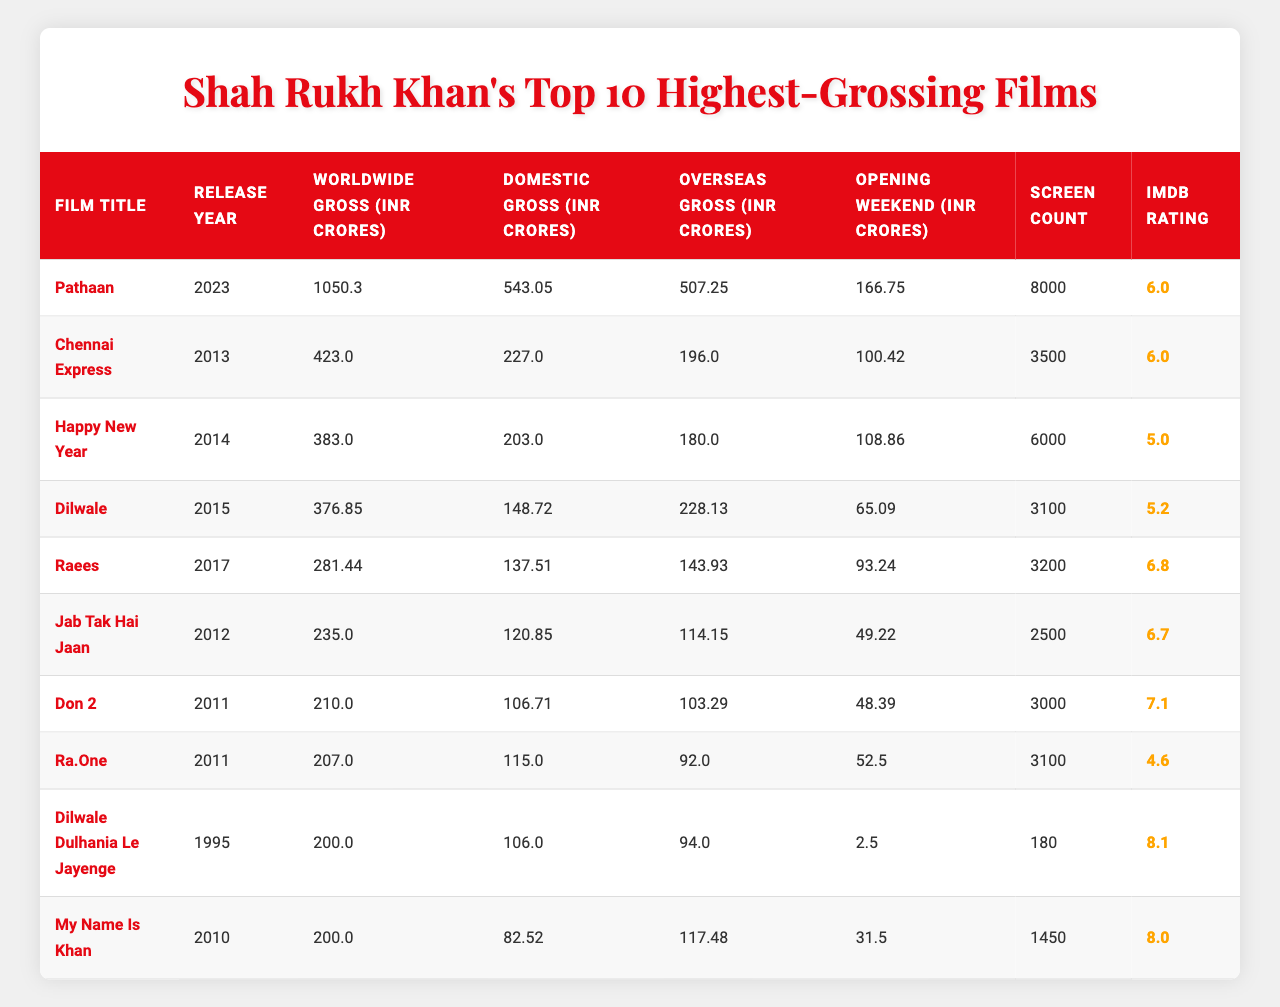What is the highest worldwide gross for a Shah Rukh Khan film? According to the table, the film "Pathaan" has the highest worldwide gross of 1050.30 INR Crores.
Answer: 1050.30 INR Crores Which film was released in 2014 and grossed over 380 INR Crores worldwide? The film "Happy New Year," released in 2014, grossed 383.00 INR Crores worldwide, which is over 380 INR Crores.
Answer: Yes What is the difference between the domestic gross of "Chennai Express" and "Raees"? The domestic gross of "Chennai Express" is 227.00 INR Crores and "Raees" is 137.51 INR Crores. The difference is 227.00 - 137.51 = 89.49 INR Crores.
Answer: 89.49 INR Crores What is the average IMDB rating of Shah Rukh Khan's top 10 films? The IMDB ratings are: 6.0, 6.0, 5.0, 5.2, 6.8, 6.7, 7.1, 4.6, 8.1, and 8.0. The sum is 6.0 + 6.0 + 5.0 + 5.2 + 6.8 + 6.7 + 7.1 + 4.6 + 8.1 + 8.0 = 59.5, and the average is 59.5 / 10 = 5.95.
Answer: 5.95 Which film has the highest opening weekend earnings, and what was the amount? "Pathaan" has the highest opening weekend earnings of 166.75 INR Crores, as seen in the table.
Answer: 166.75 INR Crores What percentage of the worldwide gross for "Dilwale" comes from its overseas earnings? "Dilwale" has a worldwide gross of 376.85 INR Crores and overseas earnings of 228.13 INR Crores. To find the percentage: (228.13 / 376.85) * 100 ≈ 60.5%.
Answer: 60.5% Did "My Name Is Khan" gross more domestically or overseas? "My Name Is Khan" grossed 82.52 INR Crores domestically and 117.48 INR Crores overseas, so it grossed more overseas.
Answer: Yes What is the total domestic gross of Shah Rukh Khan's top 10 films? The domestic gross values for the films are: 543.05, 227.00, 203.00, 148.72, 137.51, 120.85, 106.71, 115.00, 106.00, and 82.52. The total is 543.05 + 227.00 + 203.00 + 148.72 + 137.51 + 120.85 + 106.71 + 115.00 + 106.00 + 82.52 = 1,590.36 INR Crores.
Answer: 1,590.36 INR Crores How many films in the list have an IMDB rating of 7.0 or higher? The films with an IMDB rating of 7.0 or higher are "Raees" (6.8), "Don 2" (7.1), "Dilwale Dulhania Le Jayenge" (8.1), and "My Name Is Khan" (8.0). This totals 4 films.
Answer: 4 films Which film has both the lowest gross and the highest IMDB rating? "Dilwale Dulhania Le Jayenge" has the lowest gross at 200.00 INR Crores and the highest IMDB rating at 8.1 among the films in the table.
Answer: "Dilwale Dulhania Le Jayenge" 